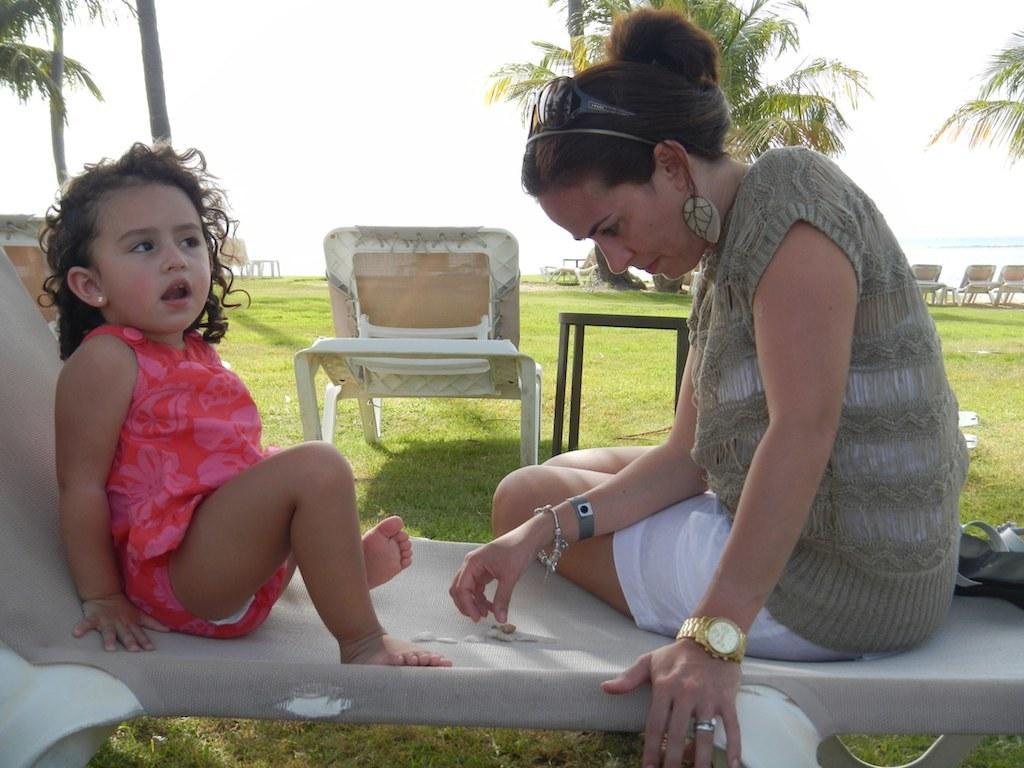In one or two sentences, can you explain what this image depicts? In this image we can see two people sitting on the chair, behind there are few chairs, trees, grass, lake and the sky. 